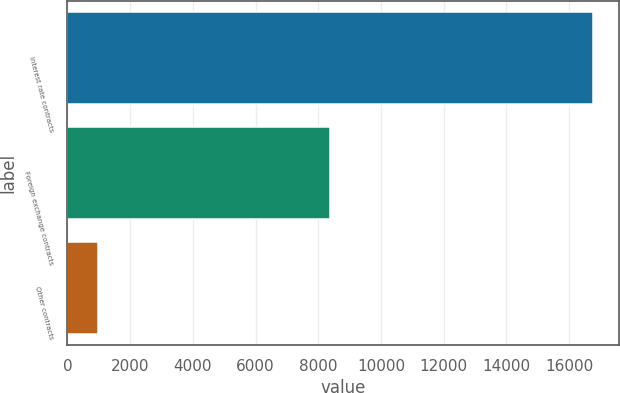Convert chart to OTSL. <chart><loc_0><loc_0><loc_500><loc_500><bar_chart><fcel>Interest rate contracts<fcel>Foreign exchange contracts<fcel>Other contracts<nl><fcel>16750<fcel>8366<fcel>981<nl></chart> 